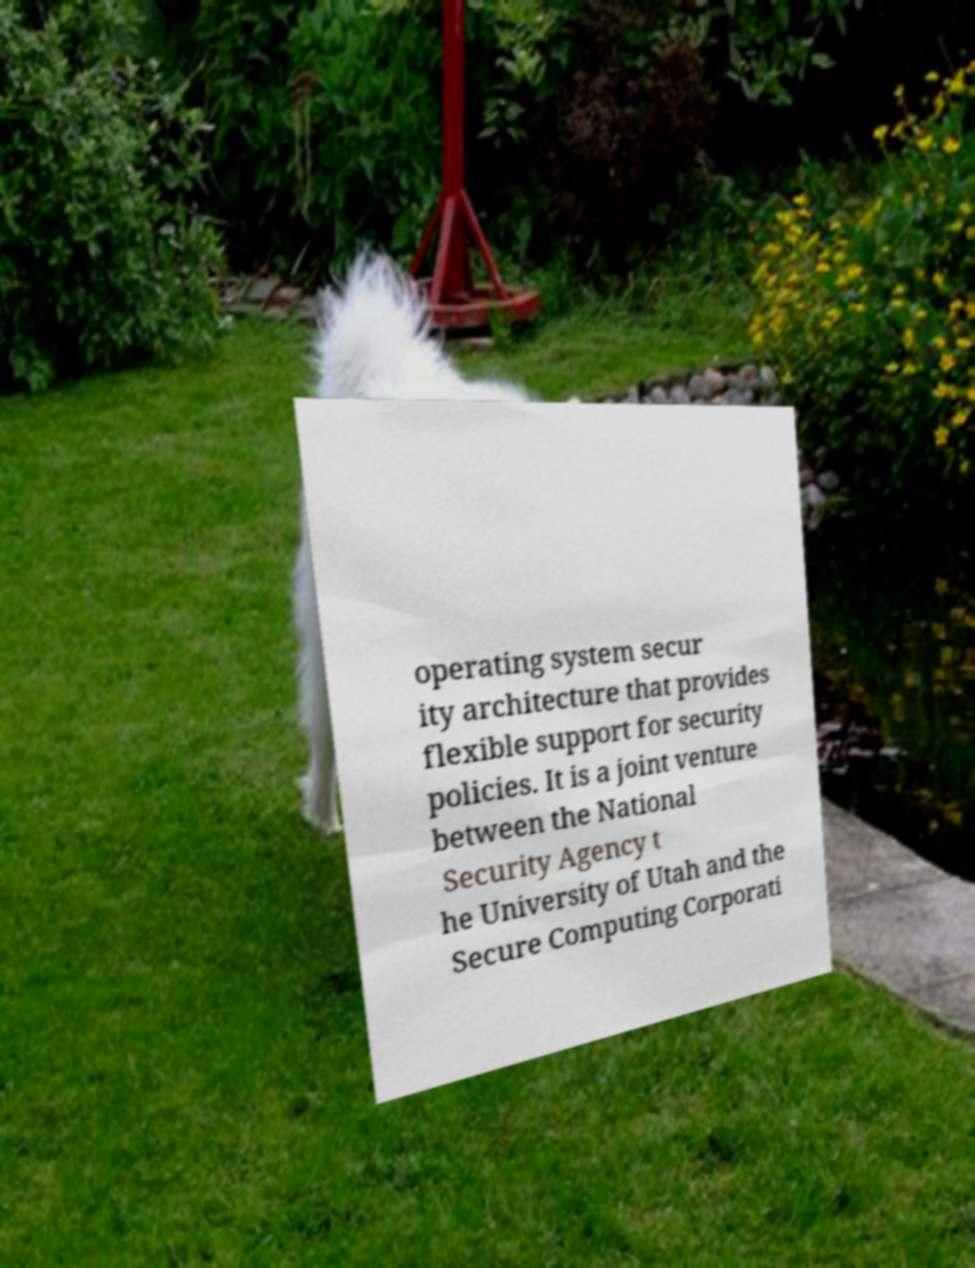Can you accurately transcribe the text from the provided image for me? operating system secur ity architecture that provides flexible support for security policies. It is a joint venture between the National Security Agency t he University of Utah and the Secure Computing Corporati 